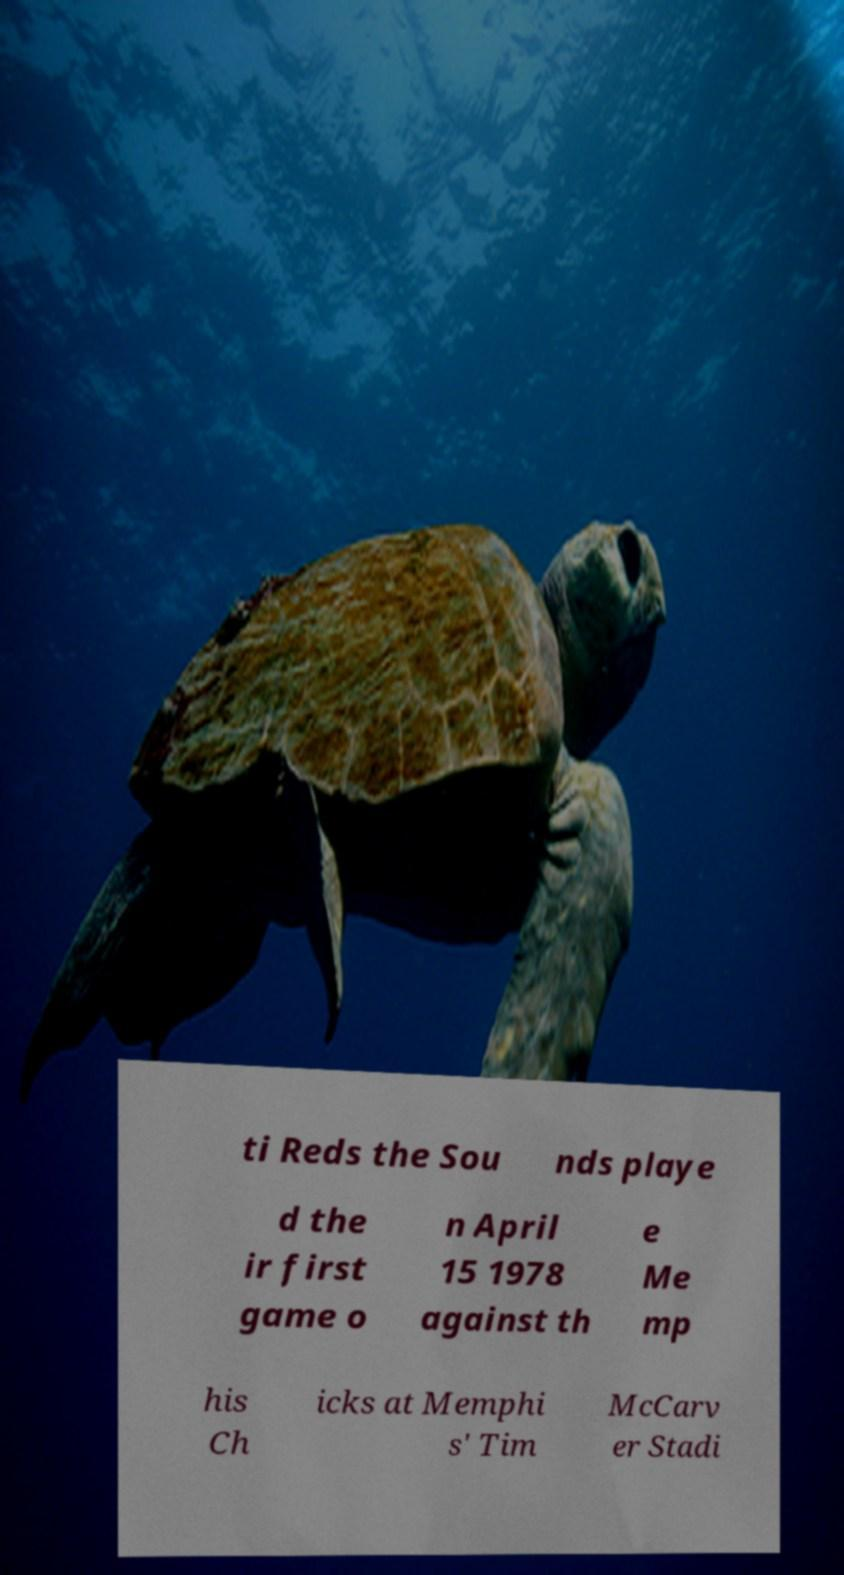Can you accurately transcribe the text from the provided image for me? ti Reds the Sou nds playe d the ir first game o n April 15 1978 against th e Me mp his Ch icks at Memphi s' Tim McCarv er Stadi 